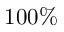<formula> <loc_0><loc_0><loc_500><loc_500>1 0 0 \%</formula> 